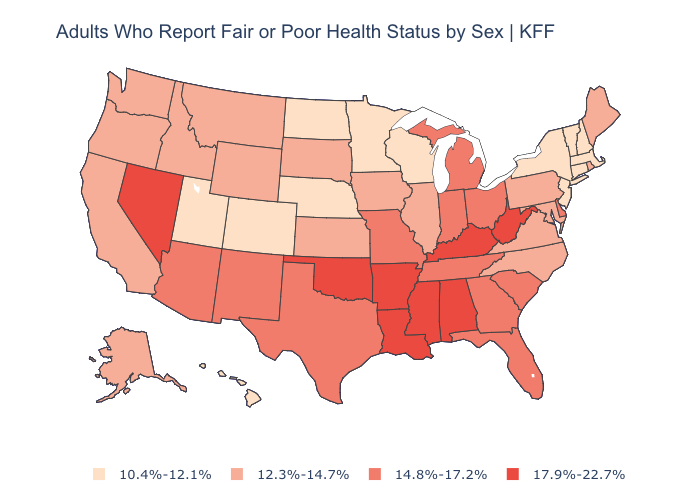What is the highest value in states that border Indiana?
Be succinct. 17.9%-22.7%. Is the legend a continuous bar?
Write a very short answer. No. What is the highest value in states that border South Carolina?
Quick response, please. 14.8%-17.2%. Does Tennessee have a higher value than Nebraska?
Keep it brief. Yes. Which states have the lowest value in the USA?
Give a very brief answer. Colorado, Connecticut, Hawaii, Massachusetts, Minnesota, Nebraska, New Hampshire, New Jersey, New York, North Dakota, Utah, Vermont, Wisconsin. Does North Dakota have the lowest value in the MidWest?
Write a very short answer. Yes. Does the first symbol in the legend represent the smallest category?
Be succinct. Yes. Among the states that border Ohio , does Kentucky have the highest value?
Answer briefly. Yes. What is the lowest value in states that border South Carolina?
Be succinct. 12.3%-14.7%. Does Virginia have the lowest value in the USA?
Quick response, please. No. Among the states that border Pennsylvania , which have the highest value?
Keep it brief. West Virginia. What is the lowest value in states that border North Carolina?
Be succinct. 12.3%-14.7%. What is the value of Illinois?
Short answer required. 12.3%-14.7%. What is the value of Oklahoma?
Write a very short answer. 17.9%-22.7%. Name the states that have a value in the range 17.9%-22.7%?
Quick response, please. Alabama, Arkansas, Kentucky, Louisiana, Mississippi, Nevada, Oklahoma, West Virginia. 